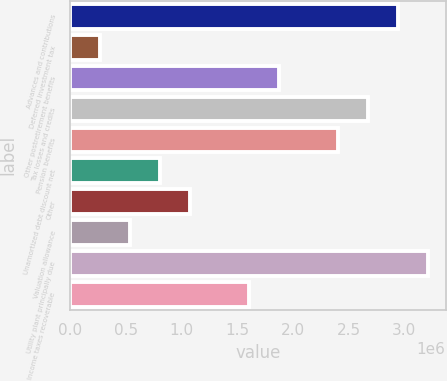Convert chart to OTSL. <chart><loc_0><loc_0><loc_500><loc_500><bar_chart><fcel>Advances and contributions<fcel>Deferred investment tax<fcel>Other postretirement benefits<fcel>Tax losses and credits<fcel>Pension benefits<fcel>Unamortized debt discount net<fcel>Other<fcel>Valuation allowance<fcel>Utility plant principally due<fcel>Income taxes recoverable<nl><fcel>2.94377e+06<fcel>271783<fcel>1.87498e+06<fcel>2.67657e+06<fcel>2.40938e+06<fcel>806181<fcel>1.07338e+06<fcel>538982<fcel>3.21097e+06<fcel>1.60778e+06<nl></chart> 